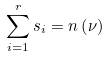Convert formula to latex. <formula><loc_0><loc_0><loc_500><loc_500>\sum _ { i = 1 } ^ { r } s _ { i } = n \left ( \nu \right )</formula> 